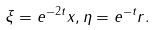Convert formula to latex. <formula><loc_0><loc_0><loc_500><loc_500>\xi = e ^ { - 2 t } x , \eta = e ^ { - t } r .</formula> 